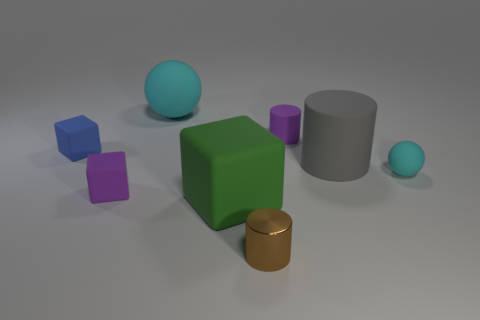Is the cyan sphere that is in front of the large cyan thing made of the same material as the big green block to the left of the big gray rubber cylinder?
Offer a terse response. Yes. Are there any matte things that have the same color as the tiny ball?
Offer a very short reply. Yes. What color is the metallic cylinder that is the same size as the blue matte block?
Give a very brief answer. Brown. Does the object behind the small purple cylinder have the same color as the big cylinder?
Make the answer very short. No. Is there a object that has the same material as the large cyan ball?
Offer a terse response. Yes. What shape is the rubber object that is the same color as the tiny rubber cylinder?
Keep it short and to the point. Cube. Are there fewer large cyan things that are behind the big cyan sphere than small yellow matte cylinders?
Your answer should be very brief. No. Do the rubber cube that is in front of the purple block and the small purple rubber cube have the same size?
Your answer should be very brief. No. How many tiny purple objects are the same shape as the blue matte thing?
Keep it short and to the point. 1. There is a purple cube that is the same material as the large sphere; what size is it?
Your answer should be compact. Small. 